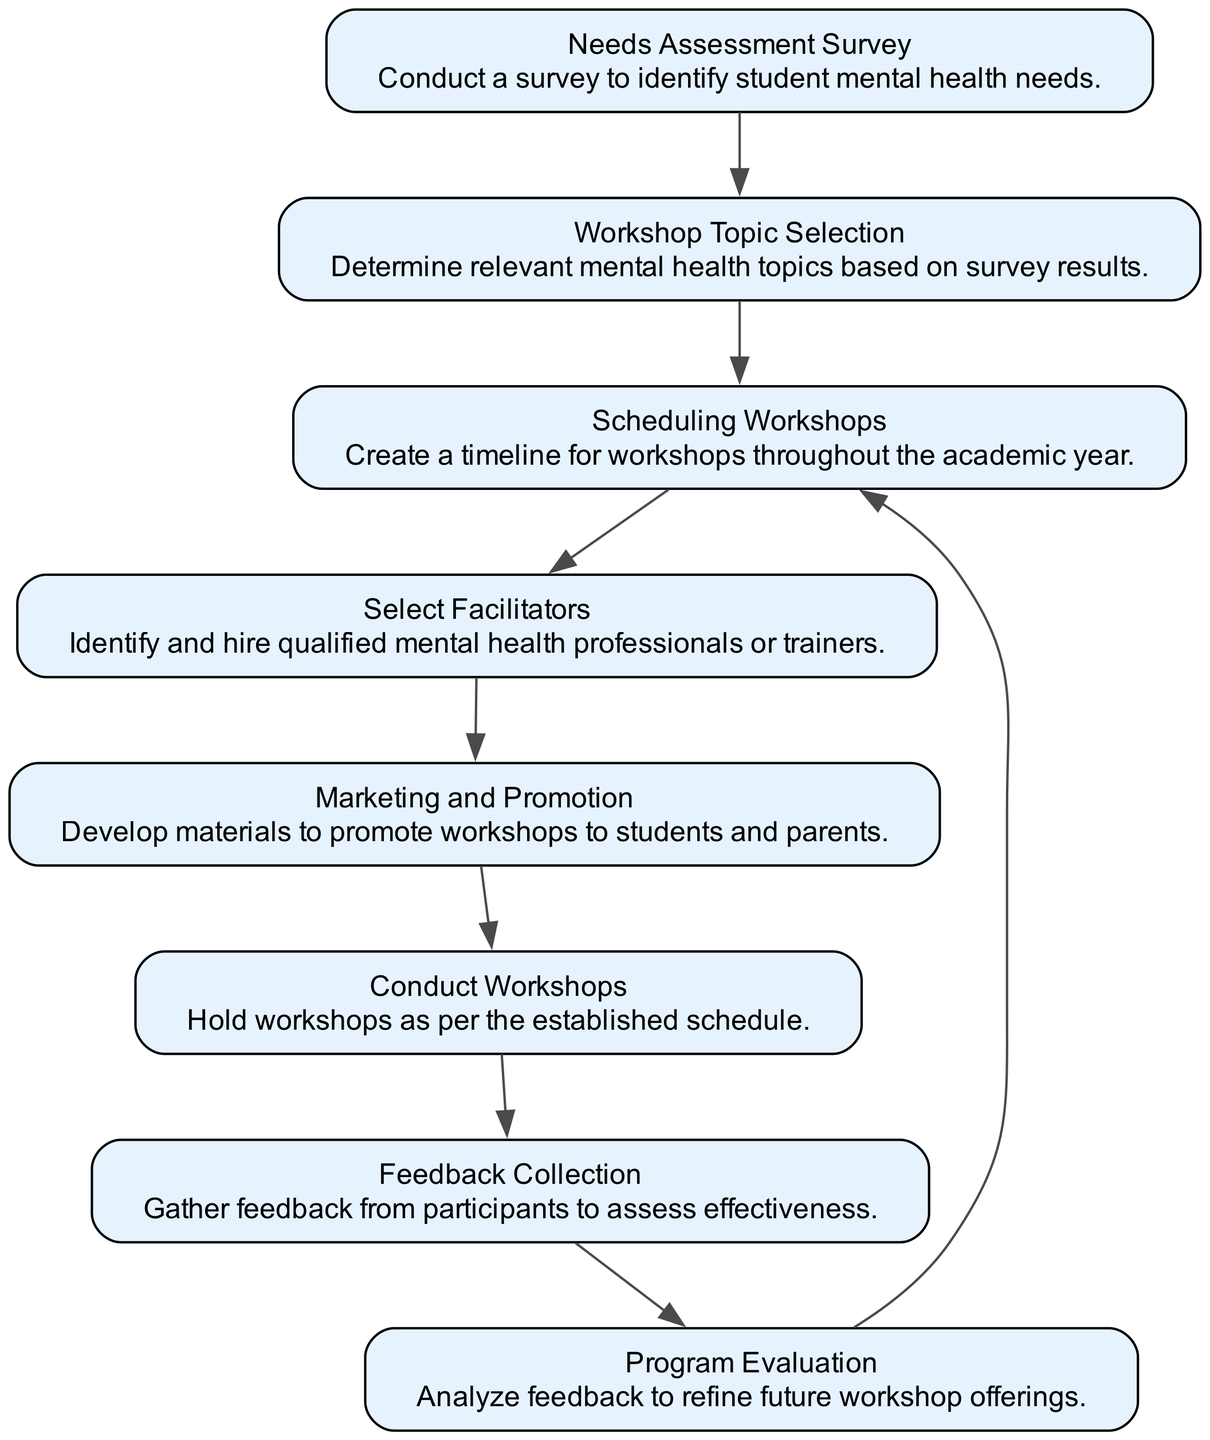What is the first step in the applied mental health workshop plan? The first step is "Needs Assessment Survey," as it is the starting node of the directed graph, indicating that this survey is fundamental to establishing the workshop's direction.
Answer: Needs Assessment Survey How many nodes are there in the diagram? The diagram contains 8 nodes, which represent different steps in the workshop implementation plan. To find this, you can count the listed nodes in the data.
Answer: 8 Which node follows "Conduct Workshops"? "Feedback Collection" follows "Conduct Workshops," as indicated by the directed edge that leads from the workshop node to the feedback node.
Answer: Feedback Collection What is the role of the node labeled "Select Facilitators"? The role of "Select Facilitators" is to identify and hire qualified mental health professionals or trainers, as described in the node's description.
Answer: Identify and hire qualified mental health professionals or trainers What is the relationship between "Workshop Topic Selection" and "Scheduling Workshops"? "Workshop Topic Selection" precedes "Scheduling Workshops" in the flow, meaning that selecting topics based on assessment needs is necessary before scheduling the workshops.
Answer: Workshop Topic Selection precedes Scheduling Workshops Which node is responsible for evaluating the program? The node responsible for evaluating the program is "Program Evaluation," which comes after "Feedback Collection" and is designed to analyze participant feedback.
Answer: Program Evaluation How many directed edges are present in the diagram? There are 8 directed edges in the diagram, which indicate the connections and flow from one step to another in the implementation process. You can count the edges listed in the data.
Answer: 8 What is the last step in the workshop implementation process? The last step in the process is "Program Evaluation," which is the final node where analysis occurs after feedback collection.
Answer: Program Evaluation Which step immediately precedes "Marketing and Promotion"? The step that immediately precedes "Marketing and Promotion" is "Select Facilitators," indicating that facilitator selection must occur before promoting the workshops.
Answer: Select Facilitators 